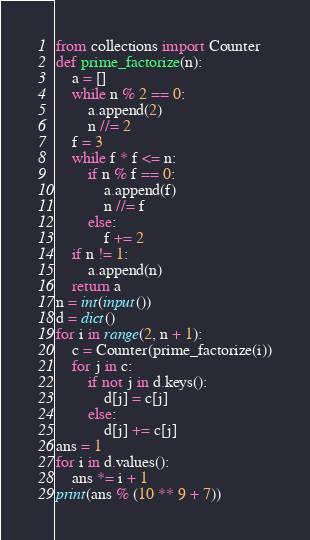Convert code to text. <code><loc_0><loc_0><loc_500><loc_500><_Python_>from collections import Counter
def prime_factorize(n):
    a = []
    while n % 2 == 0:
        a.append(2)
        n //= 2
    f = 3
    while f * f <= n:
        if n % f == 0:
            a.append(f)
            n //= f
        else:
            f += 2
    if n != 1:
        a.append(n)
    return a
n = int(input())
d = dict()
for i in range(2, n + 1):
    c = Counter(prime_factorize(i))
    for j in c:
        if not j in d.keys():
            d[j] = c[j]
        else:
            d[j] += c[j]
ans = 1
for i in d.values():
    ans *= i + 1
print(ans % (10 ** 9 + 7))</code> 